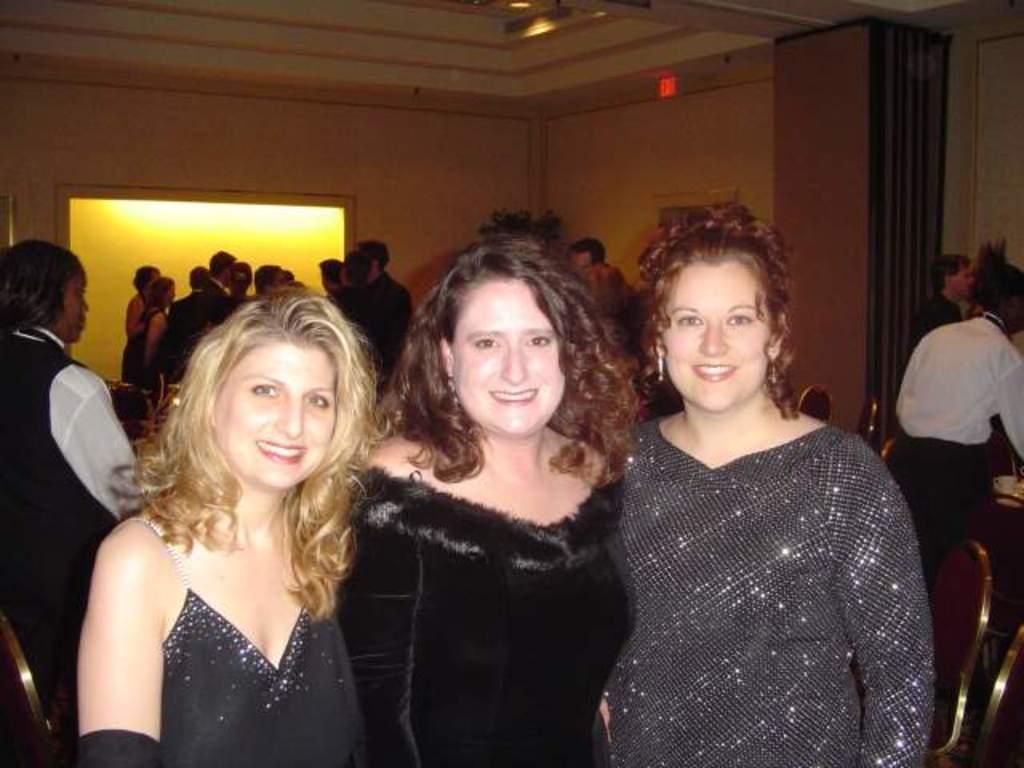Could you give a brief overview of what you see in this image? In the center of the image we can see three ladies standing and smiling. In the background there are people and we can see chairs. There is a wall and we can see lights. 